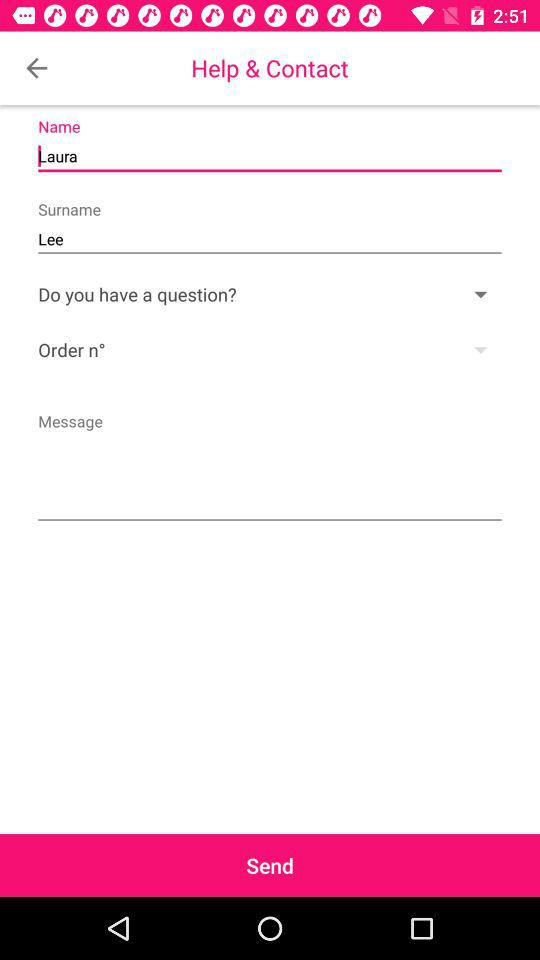What is the name of the user? The name of the user is Laura Lee. 